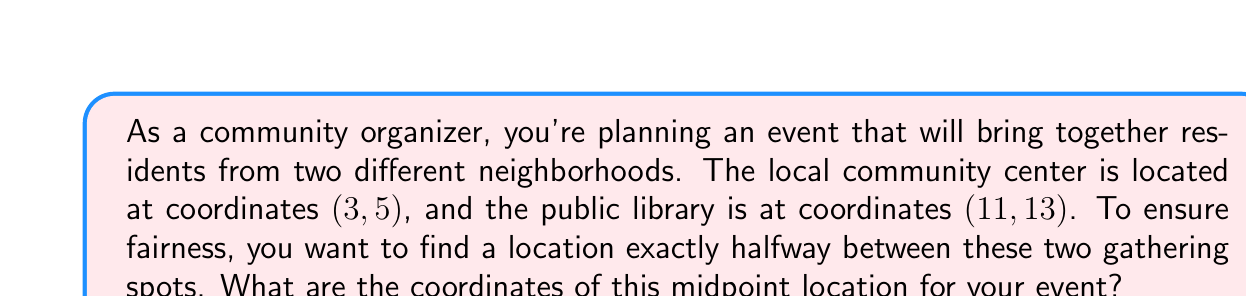Can you answer this question? To find the midpoint between two points, we use the midpoint formula:

$$ \text{Midpoint} = \left(\frac{x_1 + x_2}{2}, \frac{y_1 + y_2}{2}\right) $$

Where $(x_1, y_1)$ are the coordinates of the first point and $(x_2, y_2)$ are the coordinates of the second point.

In this case:
- Community center: $(x_1, y_1) = (3, 5)$
- Public library: $(x_2, y_2) = (11, 13)$

Let's calculate the x-coordinate of the midpoint:

$$ x_{midpoint} = \frac{x_1 + x_2}{2} = \frac{3 + 11}{2} = \frac{14}{2} = 7 $$

Now, let's calculate the y-coordinate of the midpoint:

$$ y_{midpoint} = \frac{y_1 + y_2}{2} = \frac{5 + 13}{2} = \frac{18}{2} = 9 $$

Therefore, the midpoint coordinates are (7, 9).

This location represents a fair and central point between the two community gathering spots, which aligns with your goal of bringing the neighborhoods together.
Answer: The coordinates of the midpoint location for the event are (7, 9). 